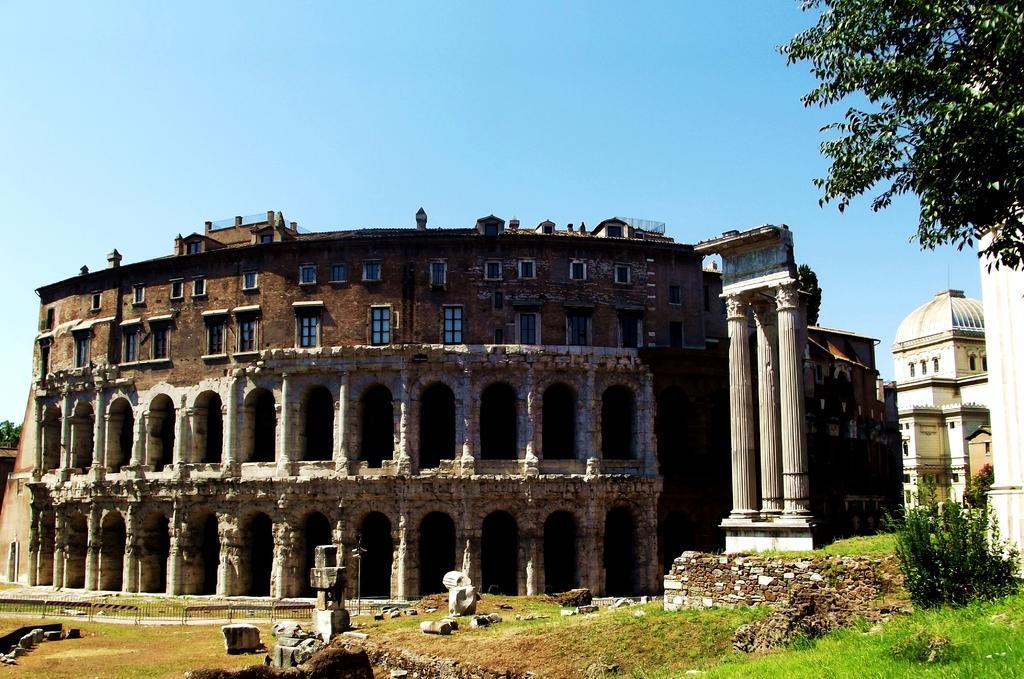Describe this image in one or two sentences. In this picture we can see buildings, pillars, trees, plants, grass, fence,some stones, some objects on the ground and we can see sky in the background. 